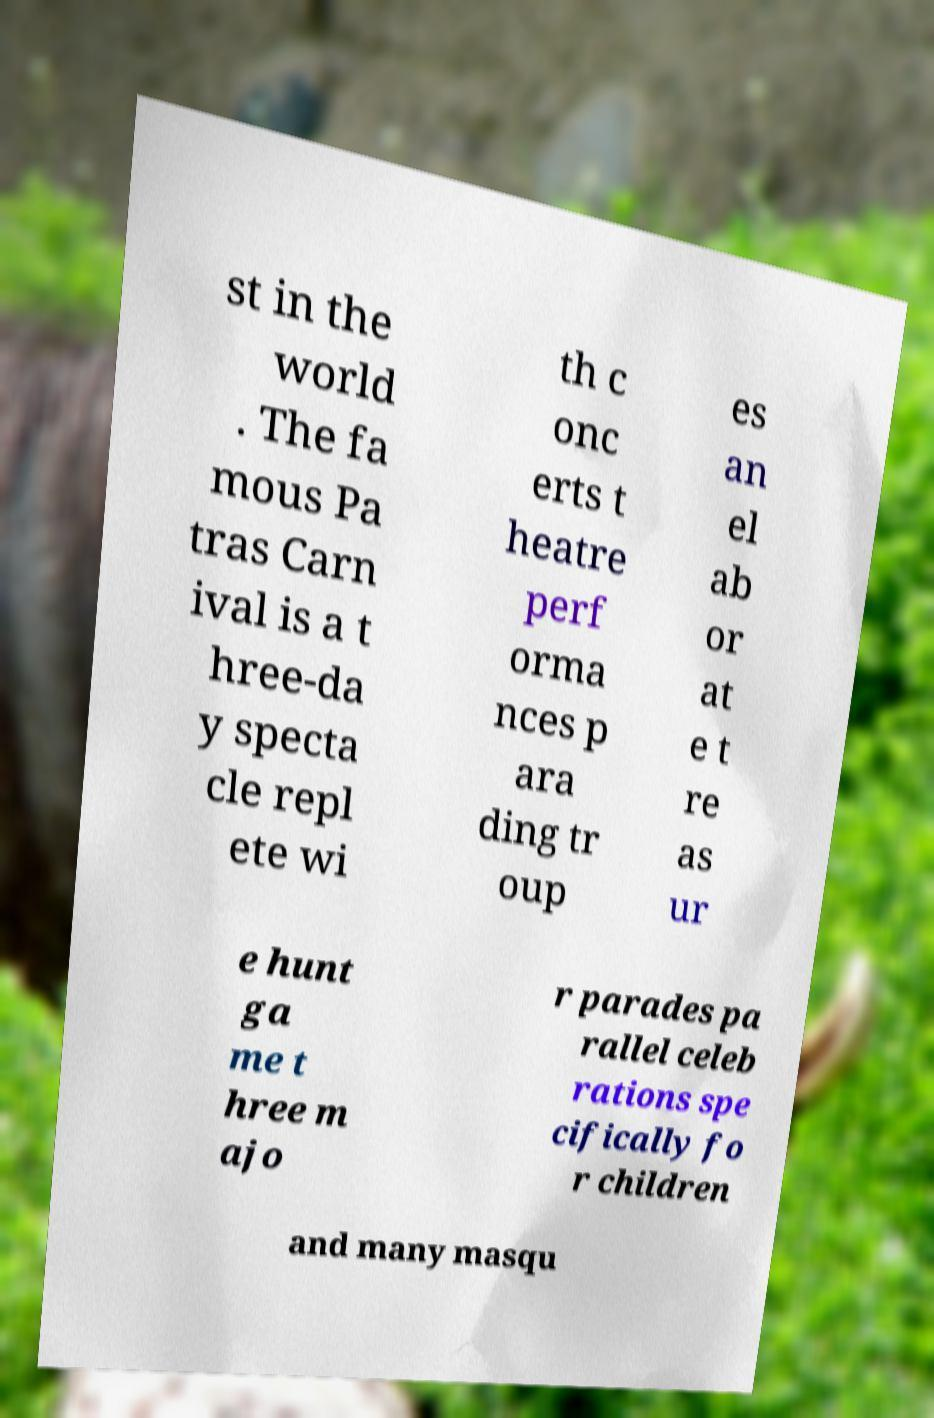Can you read and provide the text displayed in the image?This photo seems to have some interesting text. Can you extract and type it out for me? st in the world . The fa mous Pa tras Carn ival is a t hree-da y specta cle repl ete wi th c onc erts t heatre perf orma nces p ara ding tr oup es an el ab or at e t re as ur e hunt ga me t hree m ajo r parades pa rallel celeb rations spe cifically fo r children and many masqu 